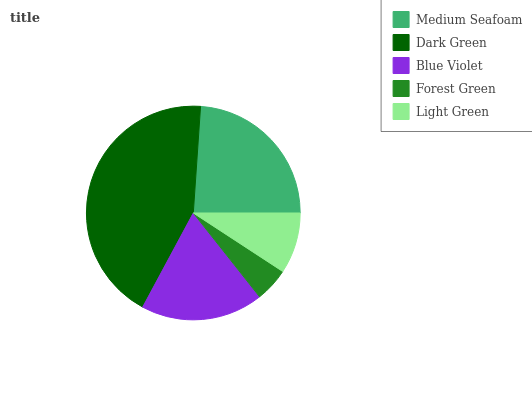Is Forest Green the minimum?
Answer yes or no. Yes. Is Dark Green the maximum?
Answer yes or no. Yes. Is Blue Violet the minimum?
Answer yes or no. No. Is Blue Violet the maximum?
Answer yes or no. No. Is Dark Green greater than Blue Violet?
Answer yes or no. Yes. Is Blue Violet less than Dark Green?
Answer yes or no. Yes. Is Blue Violet greater than Dark Green?
Answer yes or no. No. Is Dark Green less than Blue Violet?
Answer yes or no. No. Is Blue Violet the high median?
Answer yes or no. Yes. Is Blue Violet the low median?
Answer yes or no. Yes. Is Forest Green the high median?
Answer yes or no. No. Is Dark Green the low median?
Answer yes or no. No. 